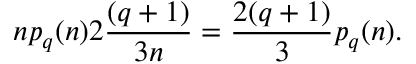<formula> <loc_0><loc_0><loc_500><loc_500>n p _ { q } ( n ) 2 \frac { ( q + 1 ) } { 3 n } = \frac { 2 ( q + 1 ) } { 3 } p _ { q } ( n ) .</formula> 